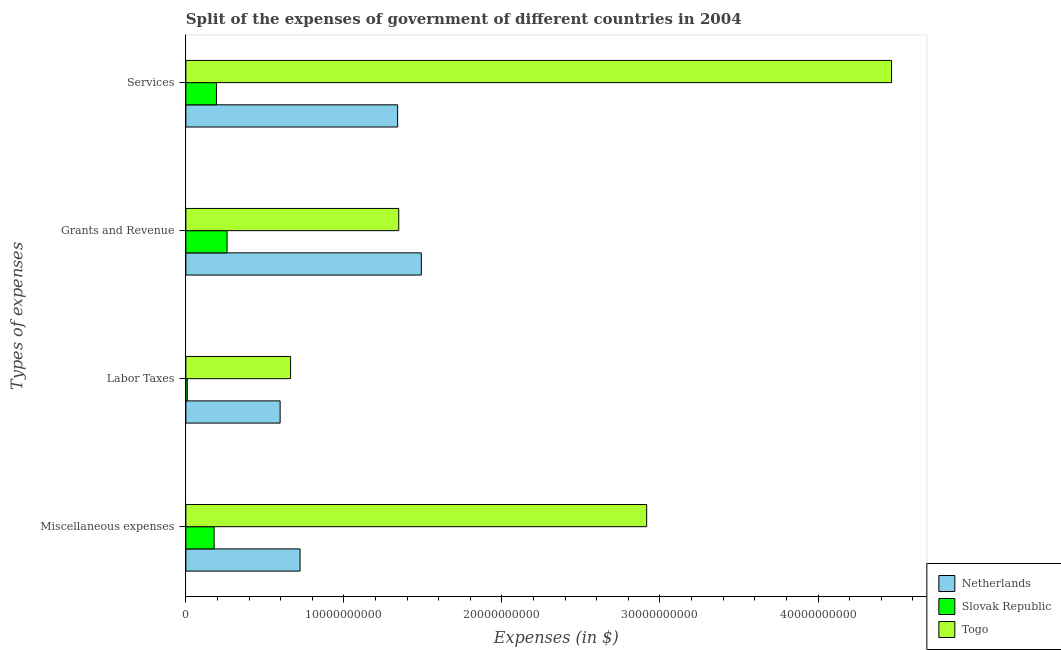How many groups of bars are there?
Keep it short and to the point. 4. Are the number of bars on each tick of the Y-axis equal?
Offer a very short reply. Yes. How many bars are there on the 3rd tick from the top?
Give a very brief answer. 3. How many bars are there on the 4th tick from the bottom?
Provide a succinct answer. 3. What is the label of the 3rd group of bars from the top?
Your answer should be very brief. Labor Taxes. What is the amount spent on grants and revenue in Netherlands?
Keep it short and to the point. 1.49e+1. Across all countries, what is the maximum amount spent on grants and revenue?
Offer a very short reply. 1.49e+1. Across all countries, what is the minimum amount spent on miscellaneous expenses?
Offer a very short reply. 1.79e+09. In which country was the amount spent on grants and revenue maximum?
Offer a terse response. Netherlands. In which country was the amount spent on miscellaneous expenses minimum?
Provide a short and direct response. Slovak Republic. What is the total amount spent on services in the graph?
Offer a terse response. 6.00e+1. What is the difference between the amount spent on grants and revenue in Togo and that in Slovak Republic?
Your answer should be compact. 1.09e+1. What is the difference between the amount spent on services in Netherlands and the amount spent on miscellaneous expenses in Togo?
Provide a succinct answer. -1.58e+1. What is the average amount spent on grants and revenue per country?
Offer a terse response. 1.03e+1. What is the difference between the amount spent on miscellaneous expenses and amount spent on labor taxes in Slovak Republic?
Keep it short and to the point. 1.70e+09. What is the ratio of the amount spent on grants and revenue in Netherlands to that in Togo?
Keep it short and to the point. 1.11. Is the amount spent on services in Netherlands less than that in Togo?
Offer a terse response. Yes. What is the difference between the highest and the second highest amount spent on services?
Offer a terse response. 3.13e+1. What is the difference between the highest and the lowest amount spent on miscellaneous expenses?
Your answer should be very brief. 2.74e+1. In how many countries, is the amount spent on grants and revenue greater than the average amount spent on grants and revenue taken over all countries?
Ensure brevity in your answer.  2. Is it the case that in every country, the sum of the amount spent on services and amount spent on miscellaneous expenses is greater than the sum of amount spent on labor taxes and amount spent on grants and revenue?
Your answer should be very brief. No. What does the 1st bar from the top in Miscellaneous expenses represents?
Offer a terse response. Togo. What does the 2nd bar from the bottom in Labor Taxes represents?
Give a very brief answer. Slovak Republic. Are all the bars in the graph horizontal?
Your response must be concise. Yes. How many countries are there in the graph?
Your answer should be very brief. 3. Does the graph contain any zero values?
Your answer should be compact. No. Does the graph contain grids?
Ensure brevity in your answer.  No. Where does the legend appear in the graph?
Keep it short and to the point. Bottom right. How many legend labels are there?
Your response must be concise. 3. What is the title of the graph?
Provide a short and direct response. Split of the expenses of government of different countries in 2004. What is the label or title of the X-axis?
Provide a succinct answer. Expenses (in $). What is the label or title of the Y-axis?
Your answer should be very brief. Types of expenses. What is the Expenses (in $) of Netherlands in Miscellaneous expenses?
Your answer should be compact. 7.22e+09. What is the Expenses (in $) of Slovak Republic in Miscellaneous expenses?
Give a very brief answer. 1.79e+09. What is the Expenses (in $) of Togo in Miscellaneous expenses?
Offer a terse response. 2.92e+1. What is the Expenses (in $) in Netherlands in Labor Taxes?
Your answer should be compact. 5.96e+09. What is the Expenses (in $) of Slovak Republic in Labor Taxes?
Make the answer very short. 8.93e+07. What is the Expenses (in $) in Togo in Labor Taxes?
Give a very brief answer. 6.63e+09. What is the Expenses (in $) of Netherlands in Grants and Revenue?
Give a very brief answer. 1.49e+1. What is the Expenses (in $) of Slovak Republic in Grants and Revenue?
Keep it short and to the point. 2.61e+09. What is the Expenses (in $) of Togo in Grants and Revenue?
Provide a succinct answer. 1.35e+1. What is the Expenses (in $) in Netherlands in Services?
Give a very brief answer. 1.34e+1. What is the Expenses (in $) in Slovak Republic in Services?
Keep it short and to the point. 1.93e+09. What is the Expenses (in $) of Togo in Services?
Give a very brief answer. 4.47e+1. Across all Types of expenses, what is the maximum Expenses (in $) in Netherlands?
Ensure brevity in your answer.  1.49e+1. Across all Types of expenses, what is the maximum Expenses (in $) of Slovak Republic?
Offer a very short reply. 2.61e+09. Across all Types of expenses, what is the maximum Expenses (in $) in Togo?
Give a very brief answer. 4.47e+1. Across all Types of expenses, what is the minimum Expenses (in $) in Netherlands?
Give a very brief answer. 5.96e+09. Across all Types of expenses, what is the minimum Expenses (in $) of Slovak Republic?
Your answer should be very brief. 8.93e+07. Across all Types of expenses, what is the minimum Expenses (in $) of Togo?
Your answer should be very brief. 6.63e+09. What is the total Expenses (in $) in Netherlands in the graph?
Offer a terse response. 4.15e+1. What is the total Expenses (in $) of Slovak Republic in the graph?
Your response must be concise. 6.42e+09. What is the total Expenses (in $) of Togo in the graph?
Provide a short and direct response. 9.39e+1. What is the difference between the Expenses (in $) of Netherlands in Miscellaneous expenses and that in Labor Taxes?
Provide a short and direct response. 1.26e+09. What is the difference between the Expenses (in $) in Slovak Republic in Miscellaneous expenses and that in Labor Taxes?
Your response must be concise. 1.70e+09. What is the difference between the Expenses (in $) in Togo in Miscellaneous expenses and that in Labor Taxes?
Provide a short and direct response. 2.25e+1. What is the difference between the Expenses (in $) of Netherlands in Miscellaneous expenses and that in Grants and Revenue?
Make the answer very short. -7.68e+09. What is the difference between the Expenses (in $) of Slovak Republic in Miscellaneous expenses and that in Grants and Revenue?
Your answer should be very brief. -8.19e+08. What is the difference between the Expenses (in $) in Togo in Miscellaneous expenses and that in Grants and Revenue?
Ensure brevity in your answer.  1.57e+1. What is the difference between the Expenses (in $) in Netherlands in Miscellaneous expenses and that in Services?
Your answer should be compact. -6.18e+09. What is the difference between the Expenses (in $) of Slovak Republic in Miscellaneous expenses and that in Services?
Provide a succinct answer. -1.47e+08. What is the difference between the Expenses (in $) in Togo in Miscellaneous expenses and that in Services?
Your answer should be very brief. -1.55e+1. What is the difference between the Expenses (in $) in Netherlands in Labor Taxes and that in Grants and Revenue?
Make the answer very short. -8.93e+09. What is the difference between the Expenses (in $) in Slovak Republic in Labor Taxes and that in Grants and Revenue?
Offer a terse response. -2.52e+09. What is the difference between the Expenses (in $) in Togo in Labor Taxes and that in Grants and Revenue?
Your answer should be compact. -6.84e+09. What is the difference between the Expenses (in $) of Netherlands in Labor Taxes and that in Services?
Provide a short and direct response. -7.44e+09. What is the difference between the Expenses (in $) of Slovak Republic in Labor Taxes and that in Services?
Ensure brevity in your answer.  -1.85e+09. What is the difference between the Expenses (in $) in Togo in Labor Taxes and that in Services?
Keep it short and to the point. -3.80e+1. What is the difference between the Expenses (in $) of Netherlands in Grants and Revenue and that in Services?
Your response must be concise. 1.50e+09. What is the difference between the Expenses (in $) in Slovak Republic in Grants and Revenue and that in Services?
Keep it short and to the point. 6.72e+08. What is the difference between the Expenses (in $) of Togo in Grants and Revenue and that in Services?
Your response must be concise. -3.12e+1. What is the difference between the Expenses (in $) of Netherlands in Miscellaneous expenses and the Expenses (in $) of Slovak Republic in Labor Taxes?
Your response must be concise. 7.13e+09. What is the difference between the Expenses (in $) of Netherlands in Miscellaneous expenses and the Expenses (in $) of Togo in Labor Taxes?
Provide a short and direct response. 5.97e+08. What is the difference between the Expenses (in $) in Slovak Republic in Miscellaneous expenses and the Expenses (in $) in Togo in Labor Taxes?
Your response must be concise. -4.84e+09. What is the difference between the Expenses (in $) in Netherlands in Miscellaneous expenses and the Expenses (in $) in Slovak Republic in Grants and Revenue?
Provide a short and direct response. 4.62e+09. What is the difference between the Expenses (in $) of Netherlands in Miscellaneous expenses and the Expenses (in $) of Togo in Grants and Revenue?
Offer a terse response. -6.25e+09. What is the difference between the Expenses (in $) in Slovak Republic in Miscellaneous expenses and the Expenses (in $) in Togo in Grants and Revenue?
Make the answer very short. -1.17e+1. What is the difference between the Expenses (in $) in Netherlands in Miscellaneous expenses and the Expenses (in $) in Slovak Republic in Services?
Offer a terse response. 5.29e+09. What is the difference between the Expenses (in $) in Netherlands in Miscellaneous expenses and the Expenses (in $) in Togo in Services?
Offer a terse response. -3.74e+1. What is the difference between the Expenses (in $) in Slovak Republic in Miscellaneous expenses and the Expenses (in $) in Togo in Services?
Provide a succinct answer. -4.29e+1. What is the difference between the Expenses (in $) in Netherlands in Labor Taxes and the Expenses (in $) in Slovak Republic in Grants and Revenue?
Offer a very short reply. 3.36e+09. What is the difference between the Expenses (in $) in Netherlands in Labor Taxes and the Expenses (in $) in Togo in Grants and Revenue?
Ensure brevity in your answer.  -7.51e+09. What is the difference between the Expenses (in $) in Slovak Republic in Labor Taxes and the Expenses (in $) in Togo in Grants and Revenue?
Provide a short and direct response. -1.34e+1. What is the difference between the Expenses (in $) in Netherlands in Labor Taxes and the Expenses (in $) in Slovak Republic in Services?
Keep it short and to the point. 4.03e+09. What is the difference between the Expenses (in $) of Netherlands in Labor Taxes and the Expenses (in $) of Togo in Services?
Your response must be concise. -3.87e+1. What is the difference between the Expenses (in $) in Slovak Republic in Labor Taxes and the Expenses (in $) in Togo in Services?
Offer a very short reply. -4.46e+1. What is the difference between the Expenses (in $) of Netherlands in Grants and Revenue and the Expenses (in $) of Slovak Republic in Services?
Give a very brief answer. 1.30e+1. What is the difference between the Expenses (in $) in Netherlands in Grants and Revenue and the Expenses (in $) in Togo in Services?
Keep it short and to the point. -2.98e+1. What is the difference between the Expenses (in $) in Slovak Republic in Grants and Revenue and the Expenses (in $) in Togo in Services?
Offer a very short reply. -4.20e+1. What is the average Expenses (in $) in Netherlands per Types of expenses?
Your answer should be very brief. 1.04e+1. What is the average Expenses (in $) in Slovak Republic per Types of expenses?
Your answer should be very brief. 1.60e+09. What is the average Expenses (in $) in Togo per Types of expenses?
Ensure brevity in your answer.  2.35e+1. What is the difference between the Expenses (in $) of Netherlands and Expenses (in $) of Slovak Republic in Miscellaneous expenses?
Your answer should be very brief. 5.44e+09. What is the difference between the Expenses (in $) in Netherlands and Expenses (in $) in Togo in Miscellaneous expenses?
Provide a short and direct response. -2.19e+1. What is the difference between the Expenses (in $) in Slovak Republic and Expenses (in $) in Togo in Miscellaneous expenses?
Provide a short and direct response. -2.74e+1. What is the difference between the Expenses (in $) in Netherlands and Expenses (in $) in Slovak Republic in Labor Taxes?
Provide a short and direct response. 5.87e+09. What is the difference between the Expenses (in $) in Netherlands and Expenses (in $) in Togo in Labor Taxes?
Offer a terse response. -6.62e+08. What is the difference between the Expenses (in $) of Slovak Republic and Expenses (in $) of Togo in Labor Taxes?
Your answer should be compact. -6.54e+09. What is the difference between the Expenses (in $) in Netherlands and Expenses (in $) in Slovak Republic in Grants and Revenue?
Provide a short and direct response. 1.23e+1. What is the difference between the Expenses (in $) of Netherlands and Expenses (in $) of Togo in Grants and Revenue?
Offer a terse response. 1.43e+09. What is the difference between the Expenses (in $) in Slovak Republic and Expenses (in $) in Togo in Grants and Revenue?
Your answer should be very brief. -1.09e+1. What is the difference between the Expenses (in $) of Netherlands and Expenses (in $) of Slovak Republic in Services?
Provide a short and direct response. 1.15e+1. What is the difference between the Expenses (in $) of Netherlands and Expenses (in $) of Togo in Services?
Provide a succinct answer. -3.13e+1. What is the difference between the Expenses (in $) in Slovak Republic and Expenses (in $) in Togo in Services?
Provide a succinct answer. -4.27e+1. What is the ratio of the Expenses (in $) of Netherlands in Miscellaneous expenses to that in Labor Taxes?
Give a very brief answer. 1.21. What is the ratio of the Expenses (in $) of Slovak Republic in Miscellaneous expenses to that in Labor Taxes?
Your answer should be very brief. 20.02. What is the ratio of the Expenses (in $) in Togo in Miscellaneous expenses to that in Labor Taxes?
Offer a very short reply. 4.4. What is the ratio of the Expenses (in $) of Netherlands in Miscellaneous expenses to that in Grants and Revenue?
Offer a terse response. 0.48. What is the ratio of the Expenses (in $) of Slovak Republic in Miscellaneous expenses to that in Grants and Revenue?
Offer a terse response. 0.69. What is the ratio of the Expenses (in $) of Togo in Miscellaneous expenses to that in Grants and Revenue?
Your response must be concise. 2.16. What is the ratio of the Expenses (in $) of Netherlands in Miscellaneous expenses to that in Services?
Give a very brief answer. 0.54. What is the ratio of the Expenses (in $) of Slovak Republic in Miscellaneous expenses to that in Services?
Offer a very short reply. 0.92. What is the ratio of the Expenses (in $) in Togo in Miscellaneous expenses to that in Services?
Your response must be concise. 0.65. What is the ratio of the Expenses (in $) in Netherlands in Labor Taxes to that in Grants and Revenue?
Offer a terse response. 0.4. What is the ratio of the Expenses (in $) of Slovak Republic in Labor Taxes to that in Grants and Revenue?
Your answer should be compact. 0.03. What is the ratio of the Expenses (in $) of Togo in Labor Taxes to that in Grants and Revenue?
Give a very brief answer. 0.49. What is the ratio of the Expenses (in $) in Netherlands in Labor Taxes to that in Services?
Your response must be concise. 0.45. What is the ratio of the Expenses (in $) in Slovak Republic in Labor Taxes to that in Services?
Your answer should be very brief. 0.05. What is the ratio of the Expenses (in $) in Togo in Labor Taxes to that in Services?
Your response must be concise. 0.15. What is the ratio of the Expenses (in $) in Netherlands in Grants and Revenue to that in Services?
Ensure brevity in your answer.  1.11. What is the ratio of the Expenses (in $) of Slovak Republic in Grants and Revenue to that in Services?
Provide a short and direct response. 1.35. What is the ratio of the Expenses (in $) in Togo in Grants and Revenue to that in Services?
Ensure brevity in your answer.  0.3. What is the difference between the highest and the second highest Expenses (in $) of Netherlands?
Keep it short and to the point. 1.50e+09. What is the difference between the highest and the second highest Expenses (in $) of Slovak Republic?
Ensure brevity in your answer.  6.72e+08. What is the difference between the highest and the second highest Expenses (in $) of Togo?
Offer a very short reply. 1.55e+1. What is the difference between the highest and the lowest Expenses (in $) of Netherlands?
Give a very brief answer. 8.93e+09. What is the difference between the highest and the lowest Expenses (in $) of Slovak Republic?
Keep it short and to the point. 2.52e+09. What is the difference between the highest and the lowest Expenses (in $) of Togo?
Your response must be concise. 3.80e+1. 